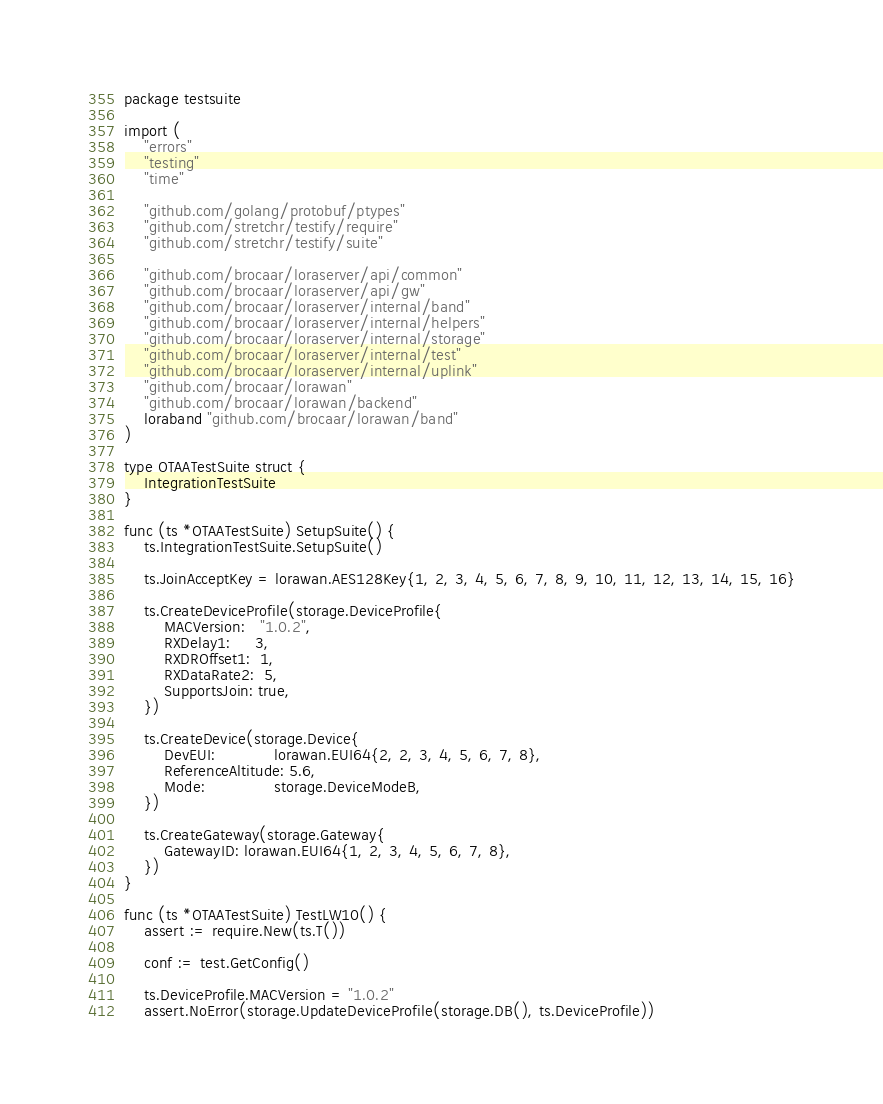Convert code to text. <code><loc_0><loc_0><loc_500><loc_500><_Go_>package testsuite

import (
	"errors"
	"testing"
	"time"

	"github.com/golang/protobuf/ptypes"
	"github.com/stretchr/testify/require"
	"github.com/stretchr/testify/suite"

	"github.com/brocaar/loraserver/api/common"
	"github.com/brocaar/loraserver/api/gw"
	"github.com/brocaar/loraserver/internal/band"
	"github.com/brocaar/loraserver/internal/helpers"
	"github.com/brocaar/loraserver/internal/storage"
	"github.com/brocaar/loraserver/internal/test"
	"github.com/brocaar/loraserver/internal/uplink"
	"github.com/brocaar/lorawan"
	"github.com/brocaar/lorawan/backend"
	loraband "github.com/brocaar/lorawan/band"
)

type OTAATestSuite struct {
	IntegrationTestSuite
}

func (ts *OTAATestSuite) SetupSuite() {
	ts.IntegrationTestSuite.SetupSuite()

	ts.JoinAcceptKey = lorawan.AES128Key{1, 2, 3, 4, 5, 6, 7, 8, 9, 10, 11, 12, 13, 14, 15, 16}

	ts.CreateDeviceProfile(storage.DeviceProfile{
		MACVersion:   "1.0.2",
		RXDelay1:     3,
		RXDROffset1:  1,
		RXDataRate2:  5,
		SupportsJoin: true,
	})

	ts.CreateDevice(storage.Device{
		DevEUI:            lorawan.EUI64{2, 2, 3, 4, 5, 6, 7, 8},
		ReferenceAltitude: 5.6,
		Mode:              storage.DeviceModeB,
	})

	ts.CreateGateway(storage.Gateway{
		GatewayID: lorawan.EUI64{1, 2, 3, 4, 5, 6, 7, 8},
	})
}

func (ts *OTAATestSuite) TestLW10() {
	assert := require.New(ts.T())

	conf := test.GetConfig()

	ts.DeviceProfile.MACVersion = "1.0.2"
	assert.NoError(storage.UpdateDeviceProfile(storage.DB(), ts.DeviceProfile))
</code> 